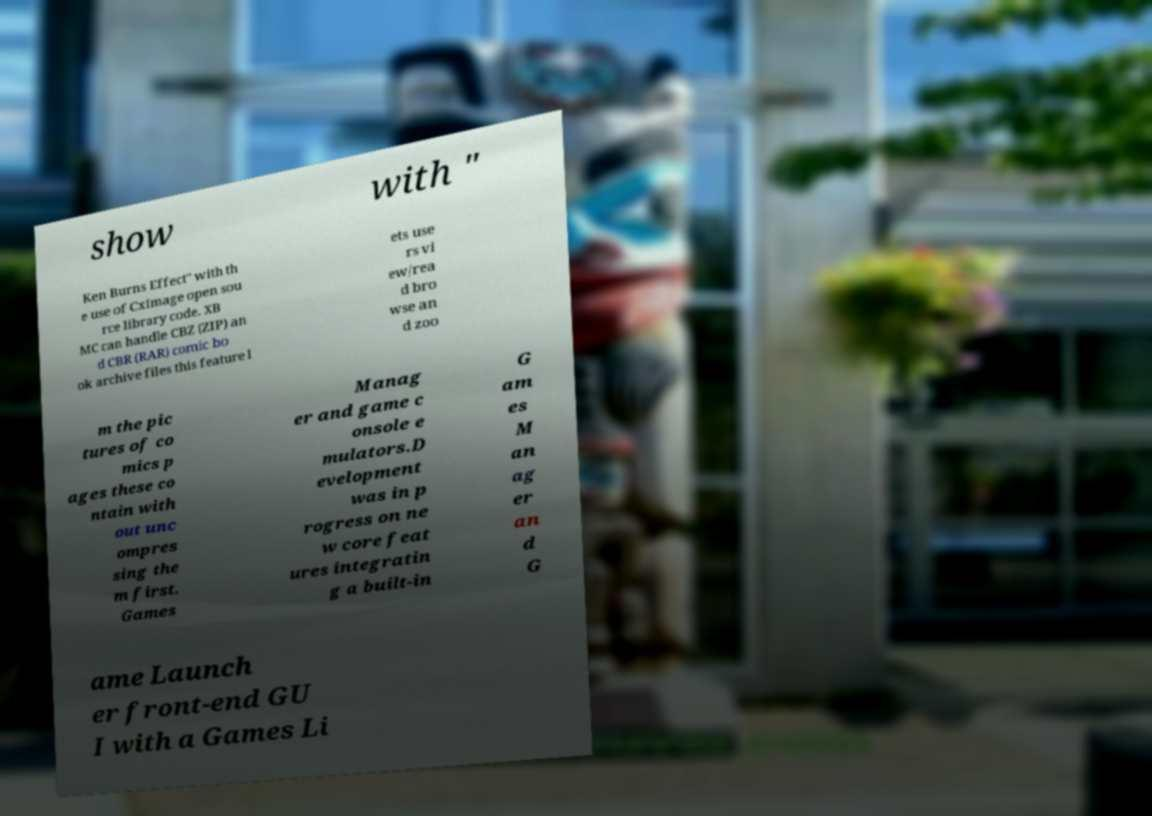There's text embedded in this image that I need extracted. Can you transcribe it verbatim? show with " Ken Burns Effect" with th e use of CxImage open sou rce library code. XB MC can handle CBZ (ZIP) an d CBR (RAR) comic bo ok archive files this feature l ets use rs vi ew/rea d bro wse an d zoo m the pic tures of co mics p ages these co ntain with out unc ompres sing the m first. Games Manag er and game c onsole e mulators.D evelopment was in p rogress on ne w core feat ures integratin g a built-in G am es M an ag er an d G ame Launch er front-end GU I with a Games Li 